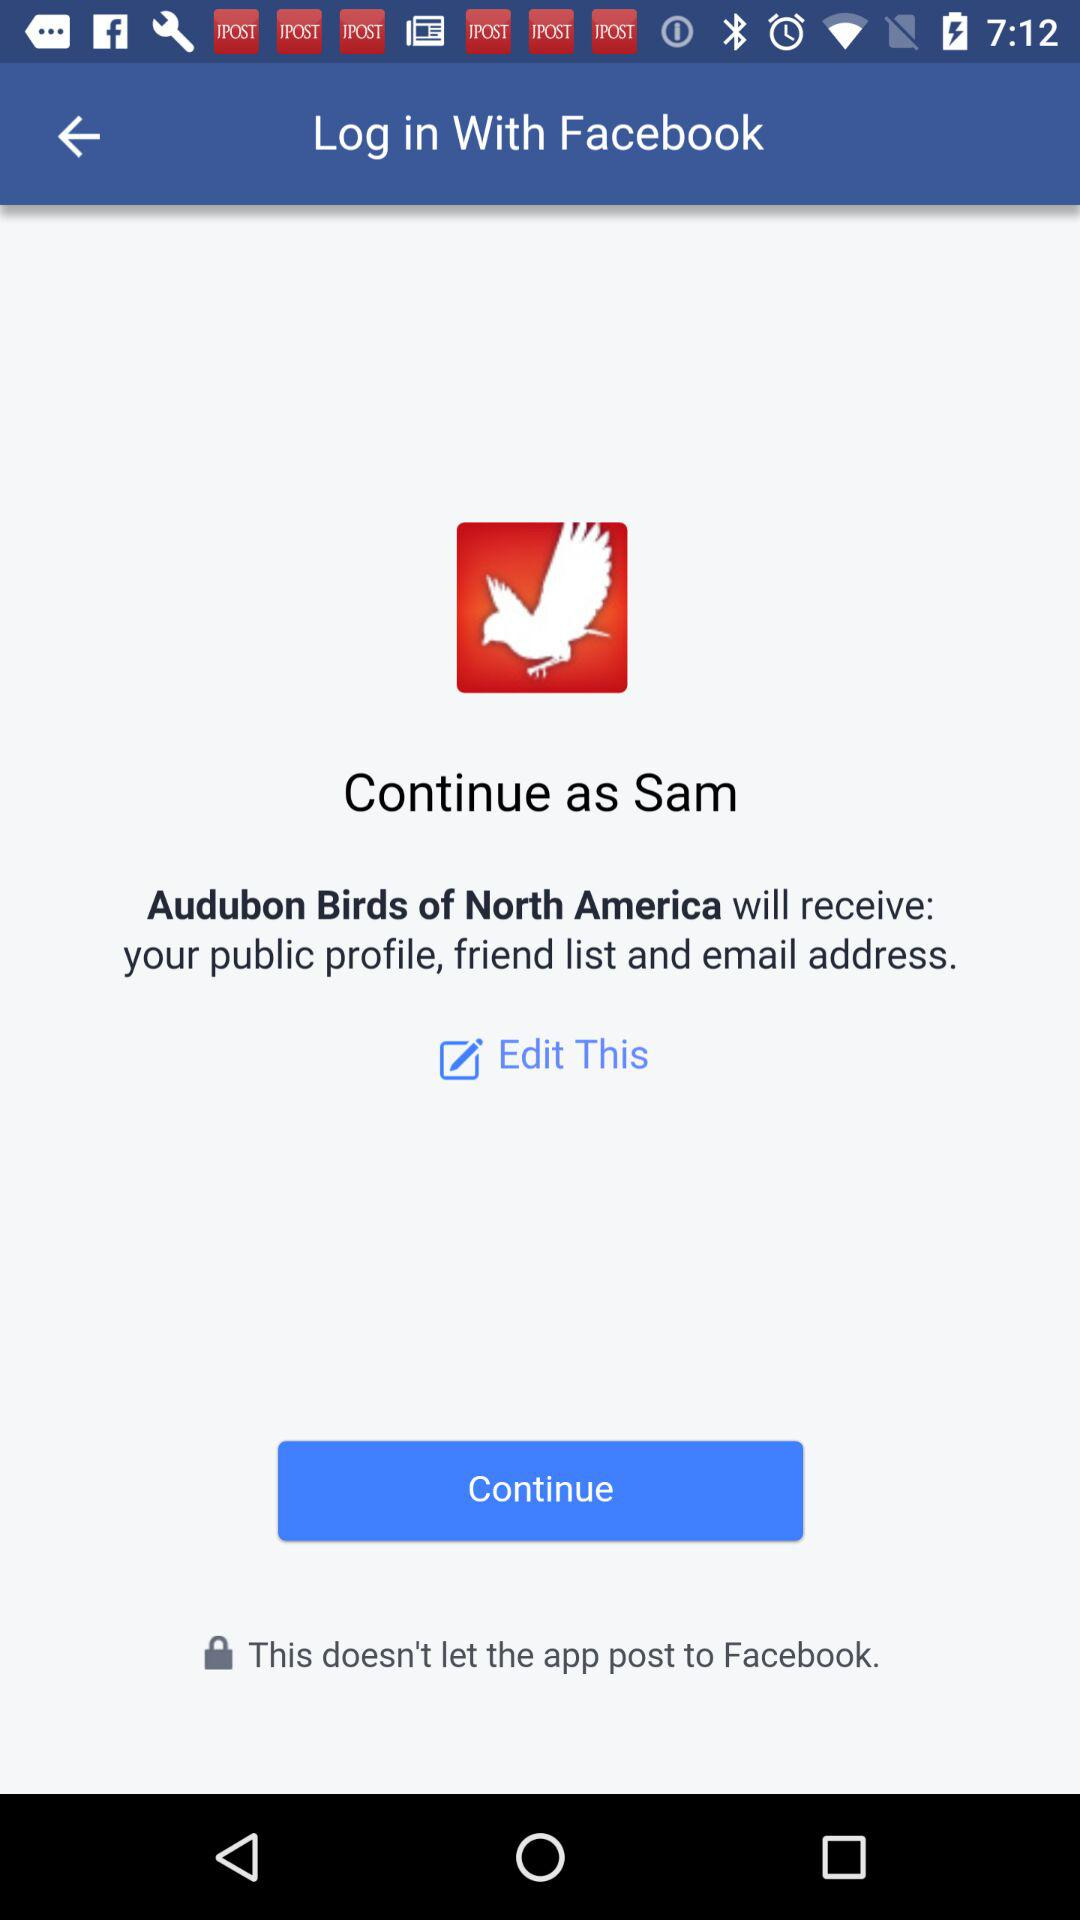What application is requesting access permission? The application requesting access permission is "Audubon Birds of North America". 